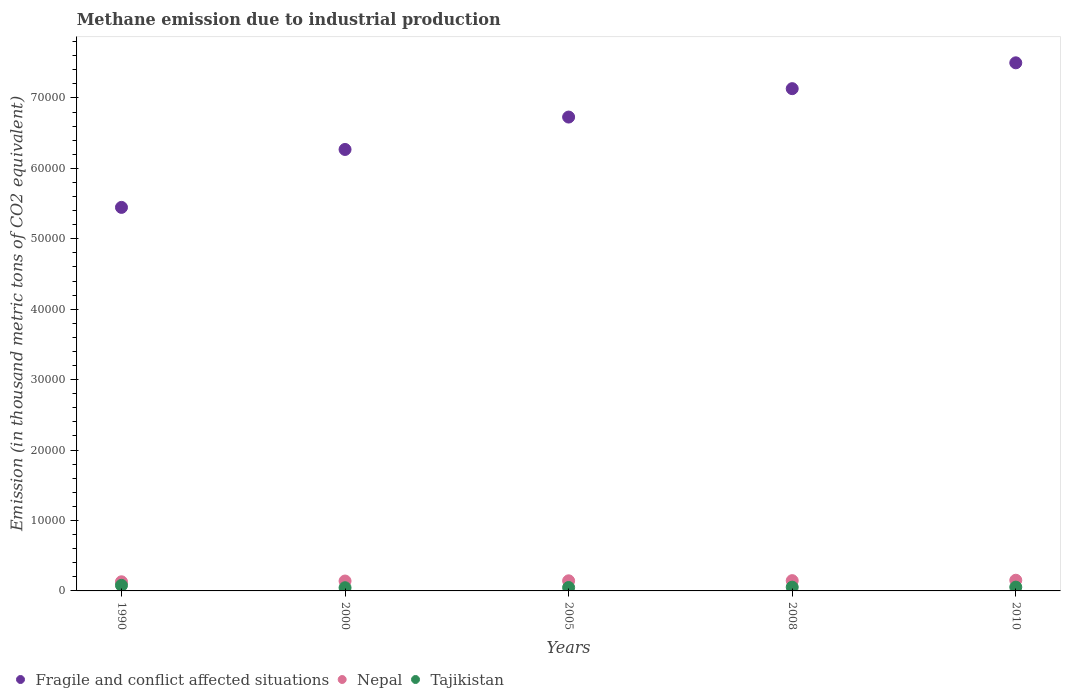What is the amount of methane emitted in Nepal in 2005?
Give a very brief answer. 1435.8. Across all years, what is the maximum amount of methane emitted in Nepal?
Provide a short and direct response. 1515.7. Across all years, what is the minimum amount of methane emitted in Fragile and conflict affected situations?
Keep it short and to the point. 5.45e+04. In which year was the amount of methane emitted in Nepal maximum?
Your answer should be very brief. 2010. What is the total amount of methane emitted in Tajikistan in the graph?
Give a very brief answer. 2802.5. What is the difference between the amount of methane emitted in Nepal in 2000 and that in 2005?
Offer a very short reply. -30.7. What is the difference between the amount of methane emitted in Nepal in 2000 and the amount of methane emitted in Tajikistan in 2010?
Provide a short and direct response. 865.4. What is the average amount of methane emitted in Nepal per year?
Provide a short and direct response. 1422.36. In the year 1990, what is the difference between the amount of methane emitted in Tajikistan and amount of methane emitted in Nepal?
Ensure brevity in your answer.  -506.2. What is the ratio of the amount of methane emitted in Nepal in 1990 to that in 2008?
Provide a short and direct response. 0.89. What is the difference between the highest and the second highest amount of methane emitted in Fragile and conflict affected situations?
Ensure brevity in your answer.  3669.2. What is the difference between the highest and the lowest amount of methane emitted in Nepal?
Provide a succinct answer. 219.1. In how many years, is the amount of methane emitted in Fragile and conflict affected situations greater than the average amount of methane emitted in Fragile and conflict affected situations taken over all years?
Your answer should be very brief. 3. Is the sum of the amount of methane emitted in Nepal in 1990 and 2005 greater than the maximum amount of methane emitted in Tajikistan across all years?
Provide a short and direct response. Yes. Is it the case that in every year, the sum of the amount of methane emitted in Nepal and amount of methane emitted in Tajikistan  is greater than the amount of methane emitted in Fragile and conflict affected situations?
Your response must be concise. No. Does the amount of methane emitted in Tajikistan monotonically increase over the years?
Your answer should be very brief. No. Is the amount of methane emitted in Tajikistan strictly less than the amount of methane emitted in Fragile and conflict affected situations over the years?
Your answer should be compact. Yes. What is the difference between two consecutive major ticks on the Y-axis?
Provide a succinct answer. 10000. Are the values on the major ticks of Y-axis written in scientific E-notation?
Provide a short and direct response. No. Does the graph contain any zero values?
Offer a terse response. No. Does the graph contain grids?
Make the answer very short. No. How many legend labels are there?
Your answer should be compact. 3. How are the legend labels stacked?
Your answer should be compact. Horizontal. What is the title of the graph?
Provide a succinct answer. Methane emission due to industrial production. What is the label or title of the Y-axis?
Provide a succinct answer. Emission (in thousand metric tons of CO2 equivalent). What is the Emission (in thousand metric tons of CO2 equivalent) in Fragile and conflict affected situations in 1990?
Ensure brevity in your answer.  5.45e+04. What is the Emission (in thousand metric tons of CO2 equivalent) of Nepal in 1990?
Ensure brevity in your answer.  1296.6. What is the Emission (in thousand metric tons of CO2 equivalent) in Tajikistan in 1990?
Your answer should be compact. 790.4. What is the Emission (in thousand metric tons of CO2 equivalent) of Fragile and conflict affected situations in 2000?
Make the answer very short. 6.27e+04. What is the Emission (in thousand metric tons of CO2 equivalent) of Nepal in 2000?
Ensure brevity in your answer.  1405.1. What is the Emission (in thousand metric tons of CO2 equivalent) in Tajikistan in 2000?
Offer a very short reply. 453.3. What is the Emission (in thousand metric tons of CO2 equivalent) in Fragile and conflict affected situations in 2005?
Provide a succinct answer. 6.73e+04. What is the Emission (in thousand metric tons of CO2 equivalent) of Nepal in 2005?
Give a very brief answer. 1435.8. What is the Emission (in thousand metric tons of CO2 equivalent) of Tajikistan in 2005?
Your response must be concise. 485. What is the Emission (in thousand metric tons of CO2 equivalent) in Fragile and conflict affected situations in 2008?
Your answer should be compact. 7.13e+04. What is the Emission (in thousand metric tons of CO2 equivalent) in Nepal in 2008?
Ensure brevity in your answer.  1458.6. What is the Emission (in thousand metric tons of CO2 equivalent) of Tajikistan in 2008?
Give a very brief answer. 534.1. What is the Emission (in thousand metric tons of CO2 equivalent) in Fragile and conflict affected situations in 2010?
Offer a very short reply. 7.50e+04. What is the Emission (in thousand metric tons of CO2 equivalent) in Nepal in 2010?
Offer a very short reply. 1515.7. What is the Emission (in thousand metric tons of CO2 equivalent) in Tajikistan in 2010?
Provide a short and direct response. 539.7. Across all years, what is the maximum Emission (in thousand metric tons of CO2 equivalent) of Fragile and conflict affected situations?
Provide a succinct answer. 7.50e+04. Across all years, what is the maximum Emission (in thousand metric tons of CO2 equivalent) of Nepal?
Give a very brief answer. 1515.7. Across all years, what is the maximum Emission (in thousand metric tons of CO2 equivalent) of Tajikistan?
Keep it short and to the point. 790.4. Across all years, what is the minimum Emission (in thousand metric tons of CO2 equivalent) in Fragile and conflict affected situations?
Ensure brevity in your answer.  5.45e+04. Across all years, what is the minimum Emission (in thousand metric tons of CO2 equivalent) in Nepal?
Make the answer very short. 1296.6. Across all years, what is the minimum Emission (in thousand metric tons of CO2 equivalent) in Tajikistan?
Offer a very short reply. 453.3. What is the total Emission (in thousand metric tons of CO2 equivalent) in Fragile and conflict affected situations in the graph?
Keep it short and to the point. 3.31e+05. What is the total Emission (in thousand metric tons of CO2 equivalent) in Nepal in the graph?
Offer a terse response. 7111.8. What is the total Emission (in thousand metric tons of CO2 equivalent) in Tajikistan in the graph?
Your response must be concise. 2802.5. What is the difference between the Emission (in thousand metric tons of CO2 equivalent) in Fragile and conflict affected situations in 1990 and that in 2000?
Give a very brief answer. -8226.1. What is the difference between the Emission (in thousand metric tons of CO2 equivalent) in Nepal in 1990 and that in 2000?
Provide a short and direct response. -108.5. What is the difference between the Emission (in thousand metric tons of CO2 equivalent) in Tajikistan in 1990 and that in 2000?
Provide a short and direct response. 337.1. What is the difference between the Emission (in thousand metric tons of CO2 equivalent) of Fragile and conflict affected situations in 1990 and that in 2005?
Your answer should be very brief. -1.28e+04. What is the difference between the Emission (in thousand metric tons of CO2 equivalent) in Nepal in 1990 and that in 2005?
Offer a very short reply. -139.2. What is the difference between the Emission (in thousand metric tons of CO2 equivalent) in Tajikistan in 1990 and that in 2005?
Provide a short and direct response. 305.4. What is the difference between the Emission (in thousand metric tons of CO2 equivalent) of Fragile and conflict affected situations in 1990 and that in 2008?
Offer a terse response. -1.69e+04. What is the difference between the Emission (in thousand metric tons of CO2 equivalent) in Nepal in 1990 and that in 2008?
Keep it short and to the point. -162. What is the difference between the Emission (in thousand metric tons of CO2 equivalent) in Tajikistan in 1990 and that in 2008?
Your response must be concise. 256.3. What is the difference between the Emission (in thousand metric tons of CO2 equivalent) of Fragile and conflict affected situations in 1990 and that in 2010?
Provide a succinct answer. -2.05e+04. What is the difference between the Emission (in thousand metric tons of CO2 equivalent) in Nepal in 1990 and that in 2010?
Ensure brevity in your answer.  -219.1. What is the difference between the Emission (in thousand metric tons of CO2 equivalent) of Tajikistan in 1990 and that in 2010?
Provide a short and direct response. 250.7. What is the difference between the Emission (in thousand metric tons of CO2 equivalent) in Fragile and conflict affected situations in 2000 and that in 2005?
Your response must be concise. -4600.6. What is the difference between the Emission (in thousand metric tons of CO2 equivalent) of Nepal in 2000 and that in 2005?
Your answer should be compact. -30.7. What is the difference between the Emission (in thousand metric tons of CO2 equivalent) of Tajikistan in 2000 and that in 2005?
Provide a succinct answer. -31.7. What is the difference between the Emission (in thousand metric tons of CO2 equivalent) of Fragile and conflict affected situations in 2000 and that in 2008?
Make the answer very short. -8634. What is the difference between the Emission (in thousand metric tons of CO2 equivalent) in Nepal in 2000 and that in 2008?
Give a very brief answer. -53.5. What is the difference between the Emission (in thousand metric tons of CO2 equivalent) of Tajikistan in 2000 and that in 2008?
Your answer should be very brief. -80.8. What is the difference between the Emission (in thousand metric tons of CO2 equivalent) of Fragile and conflict affected situations in 2000 and that in 2010?
Give a very brief answer. -1.23e+04. What is the difference between the Emission (in thousand metric tons of CO2 equivalent) in Nepal in 2000 and that in 2010?
Provide a succinct answer. -110.6. What is the difference between the Emission (in thousand metric tons of CO2 equivalent) of Tajikistan in 2000 and that in 2010?
Make the answer very short. -86.4. What is the difference between the Emission (in thousand metric tons of CO2 equivalent) in Fragile and conflict affected situations in 2005 and that in 2008?
Give a very brief answer. -4033.4. What is the difference between the Emission (in thousand metric tons of CO2 equivalent) of Nepal in 2005 and that in 2008?
Keep it short and to the point. -22.8. What is the difference between the Emission (in thousand metric tons of CO2 equivalent) in Tajikistan in 2005 and that in 2008?
Your answer should be compact. -49.1. What is the difference between the Emission (in thousand metric tons of CO2 equivalent) of Fragile and conflict affected situations in 2005 and that in 2010?
Your answer should be very brief. -7702.6. What is the difference between the Emission (in thousand metric tons of CO2 equivalent) in Nepal in 2005 and that in 2010?
Offer a very short reply. -79.9. What is the difference between the Emission (in thousand metric tons of CO2 equivalent) in Tajikistan in 2005 and that in 2010?
Your answer should be compact. -54.7. What is the difference between the Emission (in thousand metric tons of CO2 equivalent) of Fragile and conflict affected situations in 2008 and that in 2010?
Give a very brief answer. -3669.2. What is the difference between the Emission (in thousand metric tons of CO2 equivalent) of Nepal in 2008 and that in 2010?
Provide a succinct answer. -57.1. What is the difference between the Emission (in thousand metric tons of CO2 equivalent) of Tajikistan in 2008 and that in 2010?
Keep it short and to the point. -5.6. What is the difference between the Emission (in thousand metric tons of CO2 equivalent) of Fragile and conflict affected situations in 1990 and the Emission (in thousand metric tons of CO2 equivalent) of Nepal in 2000?
Offer a terse response. 5.31e+04. What is the difference between the Emission (in thousand metric tons of CO2 equivalent) of Fragile and conflict affected situations in 1990 and the Emission (in thousand metric tons of CO2 equivalent) of Tajikistan in 2000?
Give a very brief answer. 5.40e+04. What is the difference between the Emission (in thousand metric tons of CO2 equivalent) of Nepal in 1990 and the Emission (in thousand metric tons of CO2 equivalent) of Tajikistan in 2000?
Ensure brevity in your answer.  843.3. What is the difference between the Emission (in thousand metric tons of CO2 equivalent) of Fragile and conflict affected situations in 1990 and the Emission (in thousand metric tons of CO2 equivalent) of Nepal in 2005?
Provide a succinct answer. 5.30e+04. What is the difference between the Emission (in thousand metric tons of CO2 equivalent) of Fragile and conflict affected situations in 1990 and the Emission (in thousand metric tons of CO2 equivalent) of Tajikistan in 2005?
Ensure brevity in your answer.  5.40e+04. What is the difference between the Emission (in thousand metric tons of CO2 equivalent) of Nepal in 1990 and the Emission (in thousand metric tons of CO2 equivalent) of Tajikistan in 2005?
Offer a very short reply. 811.6. What is the difference between the Emission (in thousand metric tons of CO2 equivalent) in Fragile and conflict affected situations in 1990 and the Emission (in thousand metric tons of CO2 equivalent) in Nepal in 2008?
Offer a terse response. 5.30e+04. What is the difference between the Emission (in thousand metric tons of CO2 equivalent) of Fragile and conflict affected situations in 1990 and the Emission (in thousand metric tons of CO2 equivalent) of Tajikistan in 2008?
Make the answer very short. 5.39e+04. What is the difference between the Emission (in thousand metric tons of CO2 equivalent) in Nepal in 1990 and the Emission (in thousand metric tons of CO2 equivalent) in Tajikistan in 2008?
Provide a succinct answer. 762.5. What is the difference between the Emission (in thousand metric tons of CO2 equivalent) of Fragile and conflict affected situations in 1990 and the Emission (in thousand metric tons of CO2 equivalent) of Nepal in 2010?
Offer a terse response. 5.29e+04. What is the difference between the Emission (in thousand metric tons of CO2 equivalent) of Fragile and conflict affected situations in 1990 and the Emission (in thousand metric tons of CO2 equivalent) of Tajikistan in 2010?
Give a very brief answer. 5.39e+04. What is the difference between the Emission (in thousand metric tons of CO2 equivalent) of Nepal in 1990 and the Emission (in thousand metric tons of CO2 equivalent) of Tajikistan in 2010?
Give a very brief answer. 756.9. What is the difference between the Emission (in thousand metric tons of CO2 equivalent) in Fragile and conflict affected situations in 2000 and the Emission (in thousand metric tons of CO2 equivalent) in Nepal in 2005?
Keep it short and to the point. 6.13e+04. What is the difference between the Emission (in thousand metric tons of CO2 equivalent) in Fragile and conflict affected situations in 2000 and the Emission (in thousand metric tons of CO2 equivalent) in Tajikistan in 2005?
Your answer should be compact. 6.22e+04. What is the difference between the Emission (in thousand metric tons of CO2 equivalent) of Nepal in 2000 and the Emission (in thousand metric tons of CO2 equivalent) of Tajikistan in 2005?
Give a very brief answer. 920.1. What is the difference between the Emission (in thousand metric tons of CO2 equivalent) in Fragile and conflict affected situations in 2000 and the Emission (in thousand metric tons of CO2 equivalent) in Nepal in 2008?
Your response must be concise. 6.12e+04. What is the difference between the Emission (in thousand metric tons of CO2 equivalent) of Fragile and conflict affected situations in 2000 and the Emission (in thousand metric tons of CO2 equivalent) of Tajikistan in 2008?
Your answer should be compact. 6.22e+04. What is the difference between the Emission (in thousand metric tons of CO2 equivalent) of Nepal in 2000 and the Emission (in thousand metric tons of CO2 equivalent) of Tajikistan in 2008?
Provide a short and direct response. 871. What is the difference between the Emission (in thousand metric tons of CO2 equivalent) in Fragile and conflict affected situations in 2000 and the Emission (in thousand metric tons of CO2 equivalent) in Nepal in 2010?
Your answer should be compact. 6.12e+04. What is the difference between the Emission (in thousand metric tons of CO2 equivalent) of Fragile and conflict affected situations in 2000 and the Emission (in thousand metric tons of CO2 equivalent) of Tajikistan in 2010?
Make the answer very short. 6.22e+04. What is the difference between the Emission (in thousand metric tons of CO2 equivalent) in Nepal in 2000 and the Emission (in thousand metric tons of CO2 equivalent) in Tajikistan in 2010?
Your answer should be compact. 865.4. What is the difference between the Emission (in thousand metric tons of CO2 equivalent) in Fragile and conflict affected situations in 2005 and the Emission (in thousand metric tons of CO2 equivalent) in Nepal in 2008?
Keep it short and to the point. 6.58e+04. What is the difference between the Emission (in thousand metric tons of CO2 equivalent) of Fragile and conflict affected situations in 2005 and the Emission (in thousand metric tons of CO2 equivalent) of Tajikistan in 2008?
Provide a short and direct response. 6.68e+04. What is the difference between the Emission (in thousand metric tons of CO2 equivalent) in Nepal in 2005 and the Emission (in thousand metric tons of CO2 equivalent) in Tajikistan in 2008?
Make the answer very short. 901.7. What is the difference between the Emission (in thousand metric tons of CO2 equivalent) of Fragile and conflict affected situations in 2005 and the Emission (in thousand metric tons of CO2 equivalent) of Nepal in 2010?
Offer a very short reply. 6.58e+04. What is the difference between the Emission (in thousand metric tons of CO2 equivalent) of Fragile and conflict affected situations in 2005 and the Emission (in thousand metric tons of CO2 equivalent) of Tajikistan in 2010?
Provide a succinct answer. 6.68e+04. What is the difference between the Emission (in thousand metric tons of CO2 equivalent) in Nepal in 2005 and the Emission (in thousand metric tons of CO2 equivalent) in Tajikistan in 2010?
Make the answer very short. 896.1. What is the difference between the Emission (in thousand metric tons of CO2 equivalent) of Fragile and conflict affected situations in 2008 and the Emission (in thousand metric tons of CO2 equivalent) of Nepal in 2010?
Offer a very short reply. 6.98e+04. What is the difference between the Emission (in thousand metric tons of CO2 equivalent) of Fragile and conflict affected situations in 2008 and the Emission (in thousand metric tons of CO2 equivalent) of Tajikistan in 2010?
Provide a succinct answer. 7.08e+04. What is the difference between the Emission (in thousand metric tons of CO2 equivalent) in Nepal in 2008 and the Emission (in thousand metric tons of CO2 equivalent) in Tajikistan in 2010?
Make the answer very short. 918.9. What is the average Emission (in thousand metric tons of CO2 equivalent) in Fragile and conflict affected situations per year?
Your answer should be compact. 6.62e+04. What is the average Emission (in thousand metric tons of CO2 equivalent) in Nepal per year?
Provide a short and direct response. 1422.36. What is the average Emission (in thousand metric tons of CO2 equivalent) of Tajikistan per year?
Ensure brevity in your answer.  560.5. In the year 1990, what is the difference between the Emission (in thousand metric tons of CO2 equivalent) of Fragile and conflict affected situations and Emission (in thousand metric tons of CO2 equivalent) of Nepal?
Provide a short and direct response. 5.32e+04. In the year 1990, what is the difference between the Emission (in thousand metric tons of CO2 equivalent) in Fragile and conflict affected situations and Emission (in thousand metric tons of CO2 equivalent) in Tajikistan?
Your answer should be compact. 5.37e+04. In the year 1990, what is the difference between the Emission (in thousand metric tons of CO2 equivalent) of Nepal and Emission (in thousand metric tons of CO2 equivalent) of Tajikistan?
Keep it short and to the point. 506.2. In the year 2000, what is the difference between the Emission (in thousand metric tons of CO2 equivalent) of Fragile and conflict affected situations and Emission (in thousand metric tons of CO2 equivalent) of Nepal?
Offer a terse response. 6.13e+04. In the year 2000, what is the difference between the Emission (in thousand metric tons of CO2 equivalent) of Fragile and conflict affected situations and Emission (in thousand metric tons of CO2 equivalent) of Tajikistan?
Keep it short and to the point. 6.22e+04. In the year 2000, what is the difference between the Emission (in thousand metric tons of CO2 equivalent) of Nepal and Emission (in thousand metric tons of CO2 equivalent) of Tajikistan?
Keep it short and to the point. 951.8. In the year 2005, what is the difference between the Emission (in thousand metric tons of CO2 equivalent) in Fragile and conflict affected situations and Emission (in thousand metric tons of CO2 equivalent) in Nepal?
Your response must be concise. 6.59e+04. In the year 2005, what is the difference between the Emission (in thousand metric tons of CO2 equivalent) in Fragile and conflict affected situations and Emission (in thousand metric tons of CO2 equivalent) in Tajikistan?
Provide a succinct answer. 6.68e+04. In the year 2005, what is the difference between the Emission (in thousand metric tons of CO2 equivalent) of Nepal and Emission (in thousand metric tons of CO2 equivalent) of Tajikistan?
Keep it short and to the point. 950.8. In the year 2008, what is the difference between the Emission (in thousand metric tons of CO2 equivalent) of Fragile and conflict affected situations and Emission (in thousand metric tons of CO2 equivalent) of Nepal?
Make the answer very short. 6.99e+04. In the year 2008, what is the difference between the Emission (in thousand metric tons of CO2 equivalent) of Fragile and conflict affected situations and Emission (in thousand metric tons of CO2 equivalent) of Tajikistan?
Make the answer very short. 7.08e+04. In the year 2008, what is the difference between the Emission (in thousand metric tons of CO2 equivalent) of Nepal and Emission (in thousand metric tons of CO2 equivalent) of Tajikistan?
Provide a short and direct response. 924.5. In the year 2010, what is the difference between the Emission (in thousand metric tons of CO2 equivalent) in Fragile and conflict affected situations and Emission (in thousand metric tons of CO2 equivalent) in Nepal?
Offer a terse response. 7.35e+04. In the year 2010, what is the difference between the Emission (in thousand metric tons of CO2 equivalent) of Fragile and conflict affected situations and Emission (in thousand metric tons of CO2 equivalent) of Tajikistan?
Your answer should be very brief. 7.45e+04. In the year 2010, what is the difference between the Emission (in thousand metric tons of CO2 equivalent) in Nepal and Emission (in thousand metric tons of CO2 equivalent) in Tajikistan?
Your response must be concise. 976. What is the ratio of the Emission (in thousand metric tons of CO2 equivalent) of Fragile and conflict affected situations in 1990 to that in 2000?
Give a very brief answer. 0.87. What is the ratio of the Emission (in thousand metric tons of CO2 equivalent) in Nepal in 1990 to that in 2000?
Your answer should be compact. 0.92. What is the ratio of the Emission (in thousand metric tons of CO2 equivalent) of Tajikistan in 1990 to that in 2000?
Make the answer very short. 1.74. What is the ratio of the Emission (in thousand metric tons of CO2 equivalent) of Fragile and conflict affected situations in 1990 to that in 2005?
Keep it short and to the point. 0.81. What is the ratio of the Emission (in thousand metric tons of CO2 equivalent) in Nepal in 1990 to that in 2005?
Provide a short and direct response. 0.9. What is the ratio of the Emission (in thousand metric tons of CO2 equivalent) in Tajikistan in 1990 to that in 2005?
Ensure brevity in your answer.  1.63. What is the ratio of the Emission (in thousand metric tons of CO2 equivalent) of Fragile and conflict affected situations in 1990 to that in 2008?
Offer a very short reply. 0.76. What is the ratio of the Emission (in thousand metric tons of CO2 equivalent) of Tajikistan in 1990 to that in 2008?
Give a very brief answer. 1.48. What is the ratio of the Emission (in thousand metric tons of CO2 equivalent) in Fragile and conflict affected situations in 1990 to that in 2010?
Provide a succinct answer. 0.73. What is the ratio of the Emission (in thousand metric tons of CO2 equivalent) of Nepal in 1990 to that in 2010?
Your response must be concise. 0.86. What is the ratio of the Emission (in thousand metric tons of CO2 equivalent) in Tajikistan in 1990 to that in 2010?
Give a very brief answer. 1.46. What is the ratio of the Emission (in thousand metric tons of CO2 equivalent) in Fragile and conflict affected situations in 2000 to that in 2005?
Your answer should be compact. 0.93. What is the ratio of the Emission (in thousand metric tons of CO2 equivalent) in Nepal in 2000 to that in 2005?
Your answer should be very brief. 0.98. What is the ratio of the Emission (in thousand metric tons of CO2 equivalent) of Tajikistan in 2000 to that in 2005?
Make the answer very short. 0.93. What is the ratio of the Emission (in thousand metric tons of CO2 equivalent) of Fragile and conflict affected situations in 2000 to that in 2008?
Your answer should be very brief. 0.88. What is the ratio of the Emission (in thousand metric tons of CO2 equivalent) in Nepal in 2000 to that in 2008?
Give a very brief answer. 0.96. What is the ratio of the Emission (in thousand metric tons of CO2 equivalent) in Tajikistan in 2000 to that in 2008?
Offer a terse response. 0.85. What is the ratio of the Emission (in thousand metric tons of CO2 equivalent) of Fragile and conflict affected situations in 2000 to that in 2010?
Provide a short and direct response. 0.84. What is the ratio of the Emission (in thousand metric tons of CO2 equivalent) of Nepal in 2000 to that in 2010?
Your answer should be compact. 0.93. What is the ratio of the Emission (in thousand metric tons of CO2 equivalent) of Tajikistan in 2000 to that in 2010?
Ensure brevity in your answer.  0.84. What is the ratio of the Emission (in thousand metric tons of CO2 equivalent) of Fragile and conflict affected situations in 2005 to that in 2008?
Offer a terse response. 0.94. What is the ratio of the Emission (in thousand metric tons of CO2 equivalent) of Nepal in 2005 to that in 2008?
Offer a terse response. 0.98. What is the ratio of the Emission (in thousand metric tons of CO2 equivalent) of Tajikistan in 2005 to that in 2008?
Give a very brief answer. 0.91. What is the ratio of the Emission (in thousand metric tons of CO2 equivalent) in Fragile and conflict affected situations in 2005 to that in 2010?
Your answer should be very brief. 0.9. What is the ratio of the Emission (in thousand metric tons of CO2 equivalent) in Nepal in 2005 to that in 2010?
Offer a very short reply. 0.95. What is the ratio of the Emission (in thousand metric tons of CO2 equivalent) of Tajikistan in 2005 to that in 2010?
Your response must be concise. 0.9. What is the ratio of the Emission (in thousand metric tons of CO2 equivalent) in Fragile and conflict affected situations in 2008 to that in 2010?
Make the answer very short. 0.95. What is the ratio of the Emission (in thousand metric tons of CO2 equivalent) in Nepal in 2008 to that in 2010?
Make the answer very short. 0.96. What is the ratio of the Emission (in thousand metric tons of CO2 equivalent) in Tajikistan in 2008 to that in 2010?
Provide a short and direct response. 0.99. What is the difference between the highest and the second highest Emission (in thousand metric tons of CO2 equivalent) in Fragile and conflict affected situations?
Your answer should be very brief. 3669.2. What is the difference between the highest and the second highest Emission (in thousand metric tons of CO2 equivalent) in Nepal?
Your answer should be compact. 57.1. What is the difference between the highest and the second highest Emission (in thousand metric tons of CO2 equivalent) in Tajikistan?
Your answer should be compact. 250.7. What is the difference between the highest and the lowest Emission (in thousand metric tons of CO2 equivalent) in Fragile and conflict affected situations?
Make the answer very short. 2.05e+04. What is the difference between the highest and the lowest Emission (in thousand metric tons of CO2 equivalent) in Nepal?
Offer a terse response. 219.1. What is the difference between the highest and the lowest Emission (in thousand metric tons of CO2 equivalent) of Tajikistan?
Make the answer very short. 337.1. 